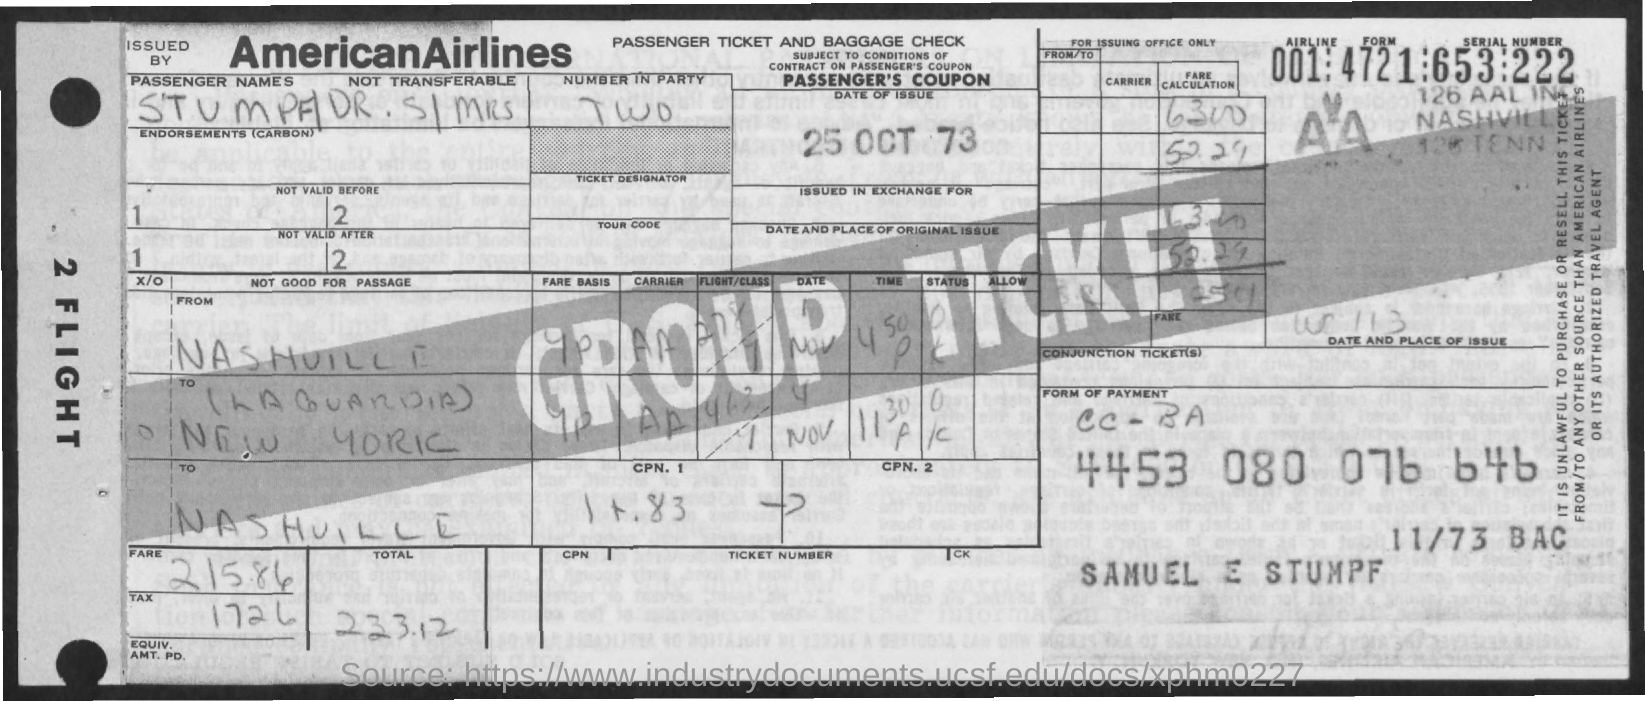Draw attention to some important aspects in this diagram. What is the tax amount? It is 1726. The date of the issue is October 25, 1973. The total is 233.12. The fare is 215.86. 